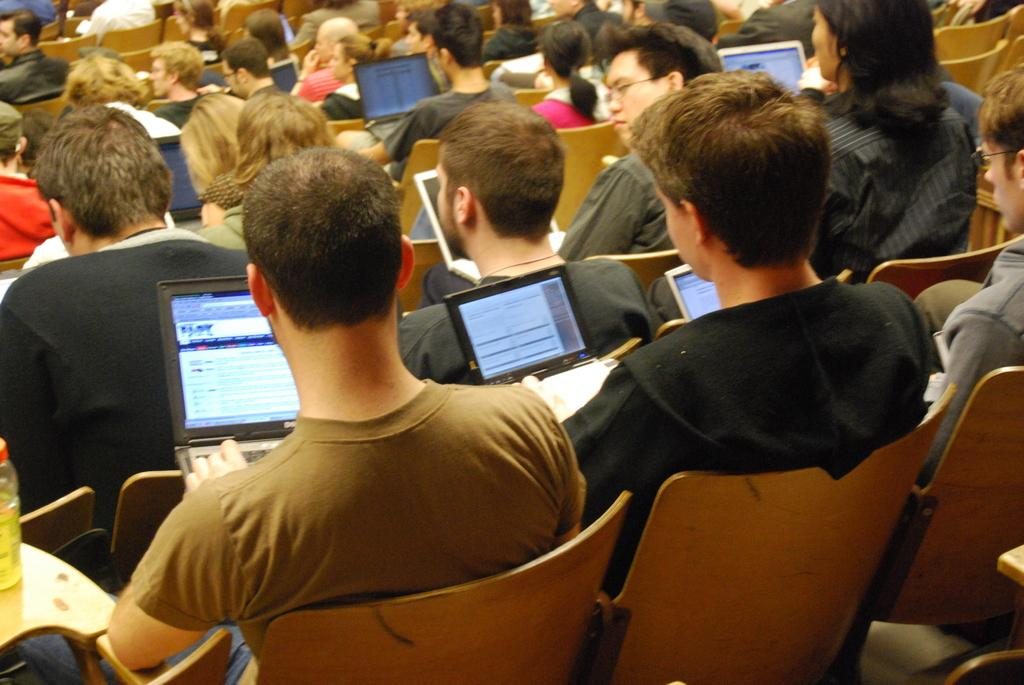What are the people in the image doing? The people in the image are sitting on chairs. What objects can be seen in the image that the people might be using? There are laptops in the image that the people might be using. How many matches are being used by the people in the image? There are no matches present in the image. What type of fowl can be seen in the image? There is no fowl present in the image. 